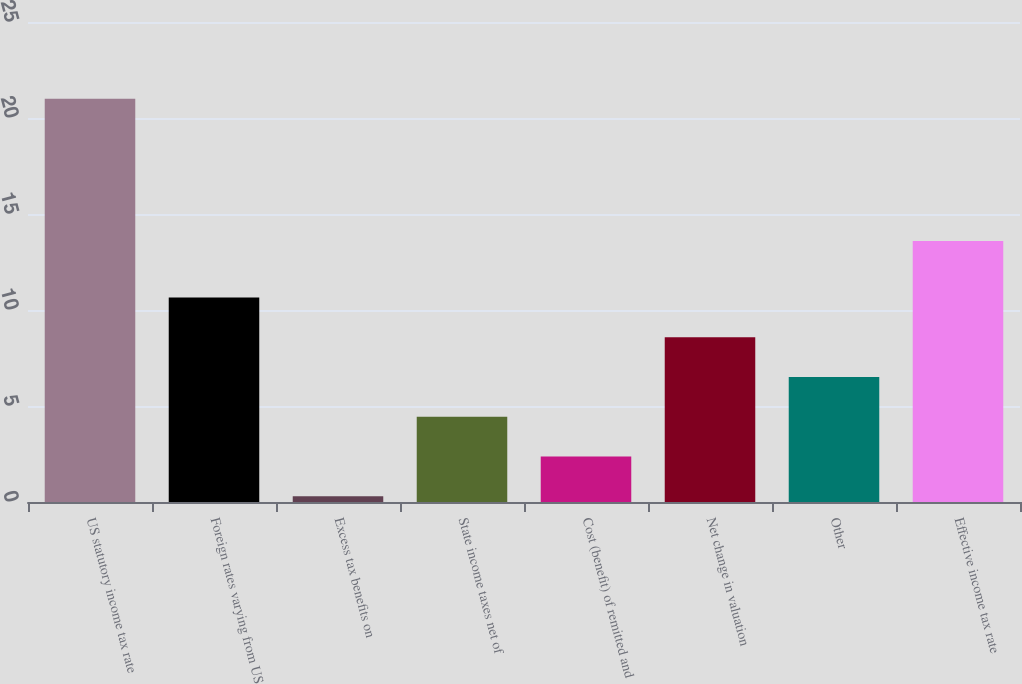<chart> <loc_0><loc_0><loc_500><loc_500><bar_chart><fcel>US statutory income tax rate<fcel>Foreign rates varying from US<fcel>Excess tax benefits on<fcel>State income taxes net of<fcel>Cost (benefit) of remitted and<fcel>Net change in valuation<fcel>Other<fcel>Effective income tax rate<nl><fcel>21<fcel>10.65<fcel>0.3<fcel>4.44<fcel>2.37<fcel>8.58<fcel>6.51<fcel>13.6<nl></chart> 